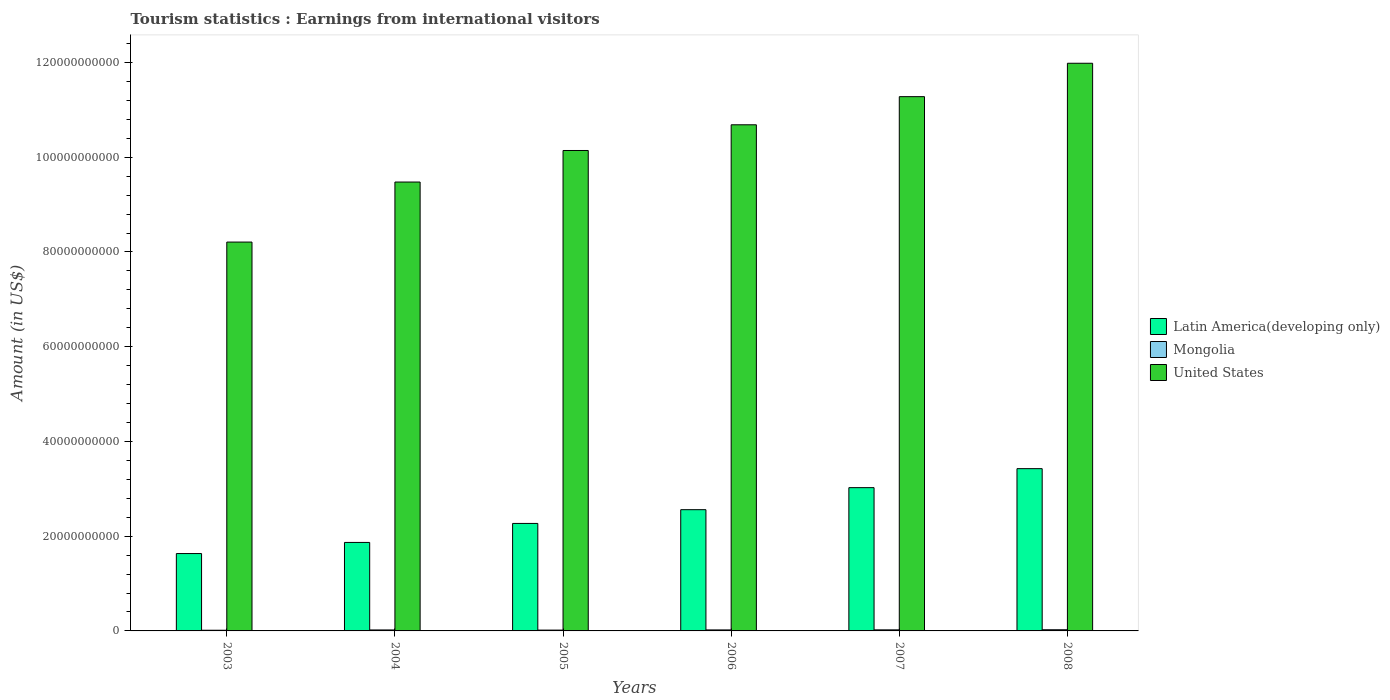Are the number of bars per tick equal to the number of legend labels?
Your answer should be compact. Yes. What is the earnings from international visitors in United States in 2005?
Your answer should be very brief. 1.01e+11. Across all years, what is the maximum earnings from international visitors in Latin America(developing only)?
Your answer should be compact. 3.43e+1. Across all years, what is the minimum earnings from international visitors in Mongolia?
Provide a succinct answer. 1.44e+08. In which year was the earnings from international visitors in Mongolia maximum?
Provide a short and direct response. 2008. What is the total earnings from international visitors in Mongolia in the graph?
Your response must be concise. 1.21e+09. What is the difference between the earnings from international visitors in United States in 2005 and that in 2007?
Provide a succinct answer. -1.14e+1. What is the difference between the earnings from international visitors in United States in 2008 and the earnings from international visitors in Latin America(developing only) in 2003?
Offer a very short reply. 1.04e+11. What is the average earnings from international visitors in Latin America(developing only) per year?
Ensure brevity in your answer.  2.46e+1. In the year 2004, what is the difference between the earnings from international visitors in United States and earnings from international visitors in Latin America(developing only)?
Keep it short and to the point. 7.61e+1. In how many years, is the earnings from international visitors in Latin America(developing only) greater than 60000000000 US$?
Your response must be concise. 0. What is the ratio of the earnings from international visitors in Mongolia in 2003 to that in 2008?
Your answer should be very brief. 0.58. Is the earnings from international visitors in Mongolia in 2003 less than that in 2005?
Make the answer very short. Yes. What is the difference between the highest and the second highest earnings from international visitors in Latin America(developing only)?
Offer a very short reply. 4.01e+09. What is the difference between the highest and the lowest earnings from international visitors in Mongolia?
Offer a terse response. 1.05e+08. What does the 1st bar from the left in 2006 represents?
Keep it short and to the point. Latin America(developing only). What does the 1st bar from the right in 2004 represents?
Your answer should be very brief. United States. Is it the case that in every year, the sum of the earnings from international visitors in Mongolia and earnings from international visitors in Latin America(developing only) is greater than the earnings from international visitors in United States?
Ensure brevity in your answer.  No. How many bars are there?
Provide a succinct answer. 18. Are all the bars in the graph horizontal?
Ensure brevity in your answer.  No. How many years are there in the graph?
Ensure brevity in your answer.  6. What is the difference between two consecutive major ticks on the Y-axis?
Offer a very short reply. 2.00e+1. Are the values on the major ticks of Y-axis written in scientific E-notation?
Ensure brevity in your answer.  No. Does the graph contain grids?
Provide a succinct answer. No. How many legend labels are there?
Offer a very short reply. 3. What is the title of the graph?
Provide a short and direct response. Tourism statistics : Earnings from international visitors. What is the label or title of the Y-axis?
Keep it short and to the point. Amount (in US$). What is the Amount (in US$) of Latin America(developing only) in 2003?
Your answer should be very brief. 1.63e+1. What is the Amount (in US$) in Mongolia in 2003?
Your response must be concise. 1.44e+08. What is the Amount (in US$) in United States in 2003?
Keep it short and to the point. 8.21e+1. What is the Amount (in US$) in Latin America(developing only) in 2004?
Ensure brevity in your answer.  1.87e+1. What is the Amount (in US$) of Mongolia in 2004?
Your answer should be compact. 2.07e+08. What is the Amount (in US$) of United States in 2004?
Offer a terse response. 9.48e+1. What is the Amount (in US$) of Latin America(developing only) in 2005?
Provide a succinct answer. 2.27e+1. What is the Amount (in US$) of Mongolia in 2005?
Your answer should be compact. 1.73e+08. What is the Amount (in US$) of United States in 2005?
Your response must be concise. 1.01e+11. What is the Amount (in US$) in Latin America(developing only) in 2006?
Offer a very short reply. 2.56e+1. What is the Amount (in US$) in Mongolia in 2006?
Your answer should be very brief. 2.12e+08. What is the Amount (in US$) in United States in 2006?
Provide a short and direct response. 1.07e+11. What is the Amount (in US$) of Latin America(developing only) in 2007?
Your answer should be compact. 3.02e+1. What is the Amount (in US$) in Mongolia in 2007?
Keep it short and to the point. 2.27e+08. What is the Amount (in US$) in United States in 2007?
Provide a succinct answer. 1.13e+11. What is the Amount (in US$) in Latin America(developing only) in 2008?
Make the answer very short. 3.43e+1. What is the Amount (in US$) of Mongolia in 2008?
Offer a terse response. 2.49e+08. What is the Amount (in US$) of United States in 2008?
Your answer should be compact. 1.20e+11. Across all years, what is the maximum Amount (in US$) in Latin America(developing only)?
Make the answer very short. 3.43e+1. Across all years, what is the maximum Amount (in US$) of Mongolia?
Offer a terse response. 2.49e+08. Across all years, what is the maximum Amount (in US$) in United States?
Your answer should be very brief. 1.20e+11. Across all years, what is the minimum Amount (in US$) of Latin America(developing only)?
Provide a short and direct response. 1.63e+1. Across all years, what is the minimum Amount (in US$) of Mongolia?
Make the answer very short. 1.44e+08. Across all years, what is the minimum Amount (in US$) of United States?
Keep it short and to the point. 8.21e+1. What is the total Amount (in US$) of Latin America(developing only) in the graph?
Your answer should be compact. 1.48e+11. What is the total Amount (in US$) of Mongolia in the graph?
Keep it short and to the point. 1.21e+09. What is the total Amount (in US$) in United States in the graph?
Make the answer very short. 6.18e+11. What is the difference between the Amount (in US$) in Latin America(developing only) in 2003 and that in 2004?
Ensure brevity in your answer.  -2.35e+09. What is the difference between the Amount (in US$) in Mongolia in 2003 and that in 2004?
Your response must be concise. -6.30e+07. What is the difference between the Amount (in US$) in United States in 2003 and that in 2004?
Your answer should be compact. -1.27e+1. What is the difference between the Amount (in US$) of Latin America(developing only) in 2003 and that in 2005?
Provide a succinct answer. -6.36e+09. What is the difference between the Amount (in US$) of Mongolia in 2003 and that in 2005?
Make the answer very short. -2.90e+07. What is the difference between the Amount (in US$) of United States in 2003 and that in 2005?
Your response must be concise. -1.93e+1. What is the difference between the Amount (in US$) of Latin America(developing only) in 2003 and that in 2006?
Make the answer very short. -9.26e+09. What is the difference between the Amount (in US$) of Mongolia in 2003 and that in 2006?
Provide a short and direct response. -6.80e+07. What is the difference between the Amount (in US$) in United States in 2003 and that in 2006?
Offer a terse response. -2.48e+1. What is the difference between the Amount (in US$) of Latin America(developing only) in 2003 and that in 2007?
Offer a terse response. -1.39e+1. What is the difference between the Amount (in US$) in Mongolia in 2003 and that in 2007?
Provide a short and direct response. -8.30e+07. What is the difference between the Amount (in US$) of United States in 2003 and that in 2007?
Your response must be concise. -3.07e+1. What is the difference between the Amount (in US$) in Latin America(developing only) in 2003 and that in 2008?
Make the answer very short. -1.79e+1. What is the difference between the Amount (in US$) of Mongolia in 2003 and that in 2008?
Your answer should be compact. -1.05e+08. What is the difference between the Amount (in US$) of United States in 2003 and that in 2008?
Provide a short and direct response. -3.77e+1. What is the difference between the Amount (in US$) in Latin America(developing only) in 2004 and that in 2005?
Your answer should be compact. -4.01e+09. What is the difference between the Amount (in US$) in Mongolia in 2004 and that in 2005?
Offer a very short reply. 3.40e+07. What is the difference between the Amount (in US$) in United States in 2004 and that in 2005?
Ensure brevity in your answer.  -6.66e+09. What is the difference between the Amount (in US$) in Latin America(developing only) in 2004 and that in 2006?
Your answer should be very brief. -6.91e+09. What is the difference between the Amount (in US$) of Mongolia in 2004 and that in 2006?
Provide a succinct answer. -5.00e+06. What is the difference between the Amount (in US$) of United States in 2004 and that in 2006?
Your response must be concise. -1.21e+1. What is the difference between the Amount (in US$) of Latin America(developing only) in 2004 and that in 2007?
Make the answer very short. -1.16e+1. What is the difference between the Amount (in US$) of Mongolia in 2004 and that in 2007?
Provide a succinct answer. -2.00e+07. What is the difference between the Amount (in US$) of United States in 2004 and that in 2007?
Your response must be concise. -1.80e+1. What is the difference between the Amount (in US$) of Latin America(developing only) in 2004 and that in 2008?
Give a very brief answer. -1.56e+1. What is the difference between the Amount (in US$) in Mongolia in 2004 and that in 2008?
Keep it short and to the point. -4.20e+07. What is the difference between the Amount (in US$) of United States in 2004 and that in 2008?
Give a very brief answer. -2.51e+1. What is the difference between the Amount (in US$) in Latin America(developing only) in 2005 and that in 2006?
Provide a short and direct response. -2.90e+09. What is the difference between the Amount (in US$) in Mongolia in 2005 and that in 2006?
Give a very brief answer. -3.90e+07. What is the difference between the Amount (in US$) of United States in 2005 and that in 2006?
Ensure brevity in your answer.  -5.43e+09. What is the difference between the Amount (in US$) in Latin America(developing only) in 2005 and that in 2007?
Offer a terse response. -7.55e+09. What is the difference between the Amount (in US$) of Mongolia in 2005 and that in 2007?
Make the answer very short. -5.40e+07. What is the difference between the Amount (in US$) in United States in 2005 and that in 2007?
Offer a very short reply. -1.14e+1. What is the difference between the Amount (in US$) in Latin America(developing only) in 2005 and that in 2008?
Offer a very short reply. -1.16e+1. What is the difference between the Amount (in US$) in Mongolia in 2005 and that in 2008?
Your answer should be compact. -7.60e+07. What is the difference between the Amount (in US$) in United States in 2005 and that in 2008?
Provide a short and direct response. -1.84e+1. What is the difference between the Amount (in US$) of Latin America(developing only) in 2006 and that in 2007?
Offer a very short reply. -4.65e+09. What is the difference between the Amount (in US$) in Mongolia in 2006 and that in 2007?
Your answer should be compact. -1.50e+07. What is the difference between the Amount (in US$) of United States in 2006 and that in 2007?
Offer a terse response. -5.94e+09. What is the difference between the Amount (in US$) in Latin America(developing only) in 2006 and that in 2008?
Provide a short and direct response. -8.66e+09. What is the difference between the Amount (in US$) of Mongolia in 2006 and that in 2008?
Make the answer very short. -3.70e+07. What is the difference between the Amount (in US$) in United States in 2006 and that in 2008?
Offer a very short reply. -1.30e+1. What is the difference between the Amount (in US$) in Latin America(developing only) in 2007 and that in 2008?
Your answer should be very brief. -4.01e+09. What is the difference between the Amount (in US$) in Mongolia in 2007 and that in 2008?
Keep it short and to the point. -2.20e+07. What is the difference between the Amount (in US$) of United States in 2007 and that in 2008?
Offer a terse response. -7.05e+09. What is the difference between the Amount (in US$) of Latin America(developing only) in 2003 and the Amount (in US$) of Mongolia in 2004?
Offer a very short reply. 1.61e+1. What is the difference between the Amount (in US$) of Latin America(developing only) in 2003 and the Amount (in US$) of United States in 2004?
Keep it short and to the point. -7.84e+1. What is the difference between the Amount (in US$) in Mongolia in 2003 and the Amount (in US$) in United States in 2004?
Give a very brief answer. -9.46e+1. What is the difference between the Amount (in US$) of Latin America(developing only) in 2003 and the Amount (in US$) of Mongolia in 2005?
Offer a terse response. 1.62e+1. What is the difference between the Amount (in US$) of Latin America(developing only) in 2003 and the Amount (in US$) of United States in 2005?
Your response must be concise. -8.51e+1. What is the difference between the Amount (in US$) in Mongolia in 2003 and the Amount (in US$) in United States in 2005?
Provide a short and direct response. -1.01e+11. What is the difference between the Amount (in US$) in Latin America(developing only) in 2003 and the Amount (in US$) in Mongolia in 2006?
Ensure brevity in your answer.  1.61e+1. What is the difference between the Amount (in US$) of Latin America(developing only) in 2003 and the Amount (in US$) of United States in 2006?
Keep it short and to the point. -9.05e+1. What is the difference between the Amount (in US$) in Mongolia in 2003 and the Amount (in US$) in United States in 2006?
Give a very brief answer. -1.07e+11. What is the difference between the Amount (in US$) of Latin America(developing only) in 2003 and the Amount (in US$) of Mongolia in 2007?
Offer a terse response. 1.61e+1. What is the difference between the Amount (in US$) of Latin America(developing only) in 2003 and the Amount (in US$) of United States in 2007?
Offer a very short reply. -9.65e+1. What is the difference between the Amount (in US$) in Mongolia in 2003 and the Amount (in US$) in United States in 2007?
Your answer should be compact. -1.13e+11. What is the difference between the Amount (in US$) of Latin America(developing only) in 2003 and the Amount (in US$) of Mongolia in 2008?
Give a very brief answer. 1.61e+1. What is the difference between the Amount (in US$) of Latin America(developing only) in 2003 and the Amount (in US$) of United States in 2008?
Make the answer very short. -1.04e+11. What is the difference between the Amount (in US$) in Mongolia in 2003 and the Amount (in US$) in United States in 2008?
Provide a short and direct response. -1.20e+11. What is the difference between the Amount (in US$) of Latin America(developing only) in 2004 and the Amount (in US$) of Mongolia in 2005?
Offer a very short reply. 1.85e+1. What is the difference between the Amount (in US$) in Latin America(developing only) in 2004 and the Amount (in US$) in United States in 2005?
Give a very brief answer. -8.27e+1. What is the difference between the Amount (in US$) of Mongolia in 2004 and the Amount (in US$) of United States in 2005?
Keep it short and to the point. -1.01e+11. What is the difference between the Amount (in US$) in Latin America(developing only) in 2004 and the Amount (in US$) in Mongolia in 2006?
Provide a succinct answer. 1.85e+1. What is the difference between the Amount (in US$) in Latin America(developing only) in 2004 and the Amount (in US$) in United States in 2006?
Provide a succinct answer. -8.82e+1. What is the difference between the Amount (in US$) of Mongolia in 2004 and the Amount (in US$) of United States in 2006?
Offer a very short reply. -1.07e+11. What is the difference between the Amount (in US$) of Latin America(developing only) in 2004 and the Amount (in US$) of Mongolia in 2007?
Your response must be concise. 1.85e+1. What is the difference between the Amount (in US$) of Latin America(developing only) in 2004 and the Amount (in US$) of United States in 2007?
Give a very brief answer. -9.41e+1. What is the difference between the Amount (in US$) in Mongolia in 2004 and the Amount (in US$) in United States in 2007?
Ensure brevity in your answer.  -1.13e+11. What is the difference between the Amount (in US$) in Latin America(developing only) in 2004 and the Amount (in US$) in Mongolia in 2008?
Offer a very short reply. 1.84e+1. What is the difference between the Amount (in US$) in Latin America(developing only) in 2004 and the Amount (in US$) in United States in 2008?
Provide a short and direct response. -1.01e+11. What is the difference between the Amount (in US$) of Mongolia in 2004 and the Amount (in US$) of United States in 2008?
Your answer should be compact. -1.20e+11. What is the difference between the Amount (in US$) in Latin America(developing only) in 2005 and the Amount (in US$) in Mongolia in 2006?
Give a very brief answer. 2.25e+1. What is the difference between the Amount (in US$) of Latin America(developing only) in 2005 and the Amount (in US$) of United States in 2006?
Provide a short and direct response. -8.42e+1. What is the difference between the Amount (in US$) of Mongolia in 2005 and the Amount (in US$) of United States in 2006?
Give a very brief answer. -1.07e+11. What is the difference between the Amount (in US$) of Latin America(developing only) in 2005 and the Amount (in US$) of Mongolia in 2007?
Offer a very short reply. 2.25e+1. What is the difference between the Amount (in US$) of Latin America(developing only) in 2005 and the Amount (in US$) of United States in 2007?
Give a very brief answer. -9.01e+1. What is the difference between the Amount (in US$) in Mongolia in 2005 and the Amount (in US$) in United States in 2007?
Your answer should be compact. -1.13e+11. What is the difference between the Amount (in US$) in Latin America(developing only) in 2005 and the Amount (in US$) in Mongolia in 2008?
Your response must be concise. 2.24e+1. What is the difference between the Amount (in US$) of Latin America(developing only) in 2005 and the Amount (in US$) of United States in 2008?
Your response must be concise. -9.71e+1. What is the difference between the Amount (in US$) in Mongolia in 2005 and the Amount (in US$) in United States in 2008?
Offer a terse response. -1.20e+11. What is the difference between the Amount (in US$) of Latin America(developing only) in 2006 and the Amount (in US$) of Mongolia in 2007?
Your answer should be compact. 2.54e+1. What is the difference between the Amount (in US$) of Latin America(developing only) in 2006 and the Amount (in US$) of United States in 2007?
Your answer should be compact. -8.72e+1. What is the difference between the Amount (in US$) of Mongolia in 2006 and the Amount (in US$) of United States in 2007?
Offer a terse response. -1.13e+11. What is the difference between the Amount (in US$) in Latin America(developing only) in 2006 and the Amount (in US$) in Mongolia in 2008?
Offer a terse response. 2.53e+1. What is the difference between the Amount (in US$) in Latin America(developing only) in 2006 and the Amount (in US$) in United States in 2008?
Provide a short and direct response. -9.42e+1. What is the difference between the Amount (in US$) in Mongolia in 2006 and the Amount (in US$) in United States in 2008?
Keep it short and to the point. -1.20e+11. What is the difference between the Amount (in US$) of Latin America(developing only) in 2007 and the Amount (in US$) of Mongolia in 2008?
Offer a terse response. 3.00e+1. What is the difference between the Amount (in US$) of Latin America(developing only) in 2007 and the Amount (in US$) of United States in 2008?
Provide a short and direct response. -8.96e+1. What is the difference between the Amount (in US$) in Mongolia in 2007 and the Amount (in US$) in United States in 2008?
Provide a short and direct response. -1.20e+11. What is the average Amount (in US$) of Latin America(developing only) per year?
Provide a succinct answer. 2.46e+1. What is the average Amount (in US$) of Mongolia per year?
Provide a short and direct response. 2.02e+08. What is the average Amount (in US$) of United States per year?
Provide a short and direct response. 1.03e+11. In the year 2003, what is the difference between the Amount (in US$) in Latin America(developing only) and Amount (in US$) in Mongolia?
Your answer should be compact. 1.62e+1. In the year 2003, what is the difference between the Amount (in US$) in Latin America(developing only) and Amount (in US$) in United States?
Your response must be concise. -6.58e+1. In the year 2003, what is the difference between the Amount (in US$) of Mongolia and Amount (in US$) of United States?
Ensure brevity in your answer.  -8.19e+1. In the year 2004, what is the difference between the Amount (in US$) of Latin America(developing only) and Amount (in US$) of Mongolia?
Offer a terse response. 1.85e+1. In the year 2004, what is the difference between the Amount (in US$) of Latin America(developing only) and Amount (in US$) of United States?
Offer a very short reply. -7.61e+1. In the year 2004, what is the difference between the Amount (in US$) of Mongolia and Amount (in US$) of United States?
Provide a succinct answer. -9.46e+1. In the year 2005, what is the difference between the Amount (in US$) in Latin America(developing only) and Amount (in US$) in Mongolia?
Ensure brevity in your answer.  2.25e+1. In the year 2005, what is the difference between the Amount (in US$) of Latin America(developing only) and Amount (in US$) of United States?
Provide a short and direct response. -7.87e+1. In the year 2005, what is the difference between the Amount (in US$) in Mongolia and Amount (in US$) in United States?
Ensure brevity in your answer.  -1.01e+11. In the year 2006, what is the difference between the Amount (in US$) of Latin America(developing only) and Amount (in US$) of Mongolia?
Your answer should be very brief. 2.54e+1. In the year 2006, what is the difference between the Amount (in US$) of Latin America(developing only) and Amount (in US$) of United States?
Offer a terse response. -8.13e+1. In the year 2006, what is the difference between the Amount (in US$) in Mongolia and Amount (in US$) in United States?
Offer a terse response. -1.07e+11. In the year 2007, what is the difference between the Amount (in US$) of Latin America(developing only) and Amount (in US$) of Mongolia?
Make the answer very short. 3.00e+1. In the year 2007, what is the difference between the Amount (in US$) in Latin America(developing only) and Amount (in US$) in United States?
Make the answer very short. -8.25e+1. In the year 2007, what is the difference between the Amount (in US$) in Mongolia and Amount (in US$) in United States?
Keep it short and to the point. -1.13e+11. In the year 2008, what is the difference between the Amount (in US$) of Latin America(developing only) and Amount (in US$) of Mongolia?
Offer a very short reply. 3.40e+1. In the year 2008, what is the difference between the Amount (in US$) in Latin America(developing only) and Amount (in US$) in United States?
Offer a very short reply. -8.56e+1. In the year 2008, what is the difference between the Amount (in US$) in Mongolia and Amount (in US$) in United States?
Give a very brief answer. -1.20e+11. What is the ratio of the Amount (in US$) of Latin America(developing only) in 2003 to that in 2004?
Offer a very short reply. 0.87. What is the ratio of the Amount (in US$) of Mongolia in 2003 to that in 2004?
Provide a short and direct response. 0.7. What is the ratio of the Amount (in US$) of United States in 2003 to that in 2004?
Ensure brevity in your answer.  0.87. What is the ratio of the Amount (in US$) of Latin America(developing only) in 2003 to that in 2005?
Provide a succinct answer. 0.72. What is the ratio of the Amount (in US$) of Mongolia in 2003 to that in 2005?
Offer a terse response. 0.83. What is the ratio of the Amount (in US$) in United States in 2003 to that in 2005?
Offer a very short reply. 0.81. What is the ratio of the Amount (in US$) of Latin America(developing only) in 2003 to that in 2006?
Offer a very short reply. 0.64. What is the ratio of the Amount (in US$) of Mongolia in 2003 to that in 2006?
Ensure brevity in your answer.  0.68. What is the ratio of the Amount (in US$) in United States in 2003 to that in 2006?
Make the answer very short. 0.77. What is the ratio of the Amount (in US$) of Latin America(developing only) in 2003 to that in 2007?
Your response must be concise. 0.54. What is the ratio of the Amount (in US$) in Mongolia in 2003 to that in 2007?
Your answer should be compact. 0.63. What is the ratio of the Amount (in US$) of United States in 2003 to that in 2007?
Make the answer very short. 0.73. What is the ratio of the Amount (in US$) in Latin America(developing only) in 2003 to that in 2008?
Give a very brief answer. 0.48. What is the ratio of the Amount (in US$) in Mongolia in 2003 to that in 2008?
Offer a very short reply. 0.58. What is the ratio of the Amount (in US$) in United States in 2003 to that in 2008?
Your answer should be very brief. 0.69. What is the ratio of the Amount (in US$) of Latin America(developing only) in 2004 to that in 2005?
Make the answer very short. 0.82. What is the ratio of the Amount (in US$) in Mongolia in 2004 to that in 2005?
Your answer should be compact. 1.2. What is the ratio of the Amount (in US$) in United States in 2004 to that in 2005?
Your answer should be very brief. 0.93. What is the ratio of the Amount (in US$) of Latin America(developing only) in 2004 to that in 2006?
Your response must be concise. 0.73. What is the ratio of the Amount (in US$) of Mongolia in 2004 to that in 2006?
Offer a very short reply. 0.98. What is the ratio of the Amount (in US$) in United States in 2004 to that in 2006?
Your answer should be very brief. 0.89. What is the ratio of the Amount (in US$) of Latin America(developing only) in 2004 to that in 2007?
Offer a terse response. 0.62. What is the ratio of the Amount (in US$) of Mongolia in 2004 to that in 2007?
Provide a succinct answer. 0.91. What is the ratio of the Amount (in US$) in United States in 2004 to that in 2007?
Ensure brevity in your answer.  0.84. What is the ratio of the Amount (in US$) of Latin America(developing only) in 2004 to that in 2008?
Give a very brief answer. 0.55. What is the ratio of the Amount (in US$) in Mongolia in 2004 to that in 2008?
Your answer should be compact. 0.83. What is the ratio of the Amount (in US$) of United States in 2004 to that in 2008?
Provide a short and direct response. 0.79. What is the ratio of the Amount (in US$) of Latin America(developing only) in 2005 to that in 2006?
Keep it short and to the point. 0.89. What is the ratio of the Amount (in US$) of Mongolia in 2005 to that in 2006?
Provide a short and direct response. 0.82. What is the ratio of the Amount (in US$) of United States in 2005 to that in 2006?
Your answer should be compact. 0.95. What is the ratio of the Amount (in US$) of Latin America(developing only) in 2005 to that in 2007?
Offer a very short reply. 0.75. What is the ratio of the Amount (in US$) in Mongolia in 2005 to that in 2007?
Ensure brevity in your answer.  0.76. What is the ratio of the Amount (in US$) of United States in 2005 to that in 2007?
Give a very brief answer. 0.9. What is the ratio of the Amount (in US$) of Latin America(developing only) in 2005 to that in 2008?
Offer a terse response. 0.66. What is the ratio of the Amount (in US$) in Mongolia in 2005 to that in 2008?
Give a very brief answer. 0.69. What is the ratio of the Amount (in US$) in United States in 2005 to that in 2008?
Offer a terse response. 0.85. What is the ratio of the Amount (in US$) of Latin America(developing only) in 2006 to that in 2007?
Offer a terse response. 0.85. What is the ratio of the Amount (in US$) of Mongolia in 2006 to that in 2007?
Offer a very short reply. 0.93. What is the ratio of the Amount (in US$) of United States in 2006 to that in 2007?
Your answer should be compact. 0.95. What is the ratio of the Amount (in US$) in Latin America(developing only) in 2006 to that in 2008?
Offer a terse response. 0.75. What is the ratio of the Amount (in US$) in Mongolia in 2006 to that in 2008?
Make the answer very short. 0.85. What is the ratio of the Amount (in US$) of United States in 2006 to that in 2008?
Provide a succinct answer. 0.89. What is the ratio of the Amount (in US$) in Latin America(developing only) in 2007 to that in 2008?
Ensure brevity in your answer.  0.88. What is the ratio of the Amount (in US$) in Mongolia in 2007 to that in 2008?
Provide a short and direct response. 0.91. What is the ratio of the Amount (in US$) of United States in 2007 to that in 2008?
Offer a terse response. 0.94. What is the difference between the highest and the second highest Amount (in US$) in Latin America(developing only)?
Your answer should be very brief. 4.01e+09. What is the difference between the highest and the second highest Amount (in US$) of Mongolia?
Your answer should be compact. 2.20e+07. What is the difference between the highest and the second highest Amount (in US$) in United States?
Offer a terse response. 7.05e+09. What is the difference between the highest and the lowest Amount (in US$) of Latin America(developing only)?
Keep it short and to the point. 1.79e+1. What is the difference between the highest and the lowest Amount (in US$) of Mongolia?
Offer a terse response. 1.05e+08. What is the difference between the highest and the lowest Amount (in US$) of United States?
Keep it short and to the point. 3.77e+1. 